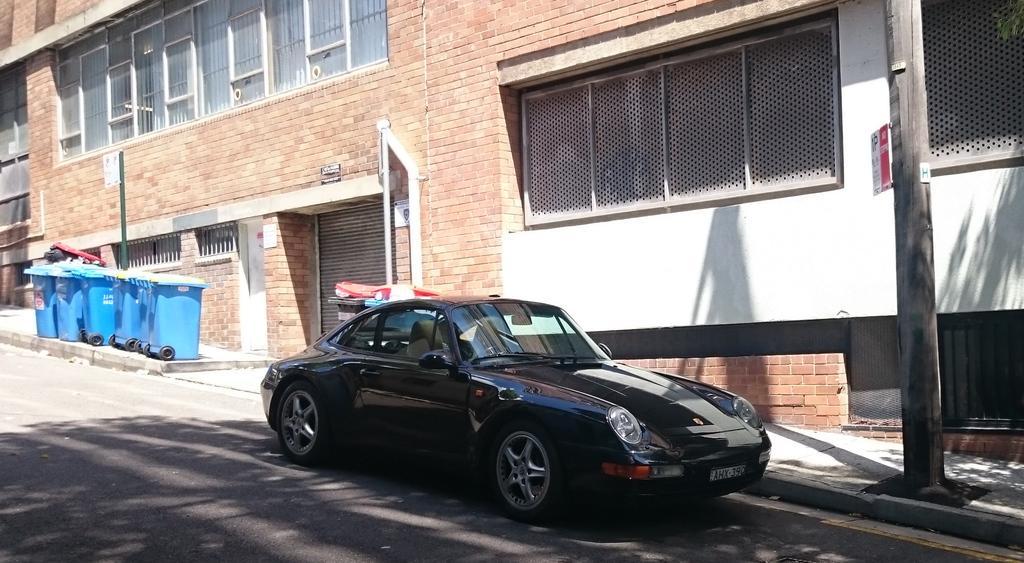Please provide a concise description of this image. In the picture we can see a car which is parked on the road near the path and building and to the building we can see some windows and shutter and near to the building we can also see some dustbin boxes with wheels are placed on the path. 